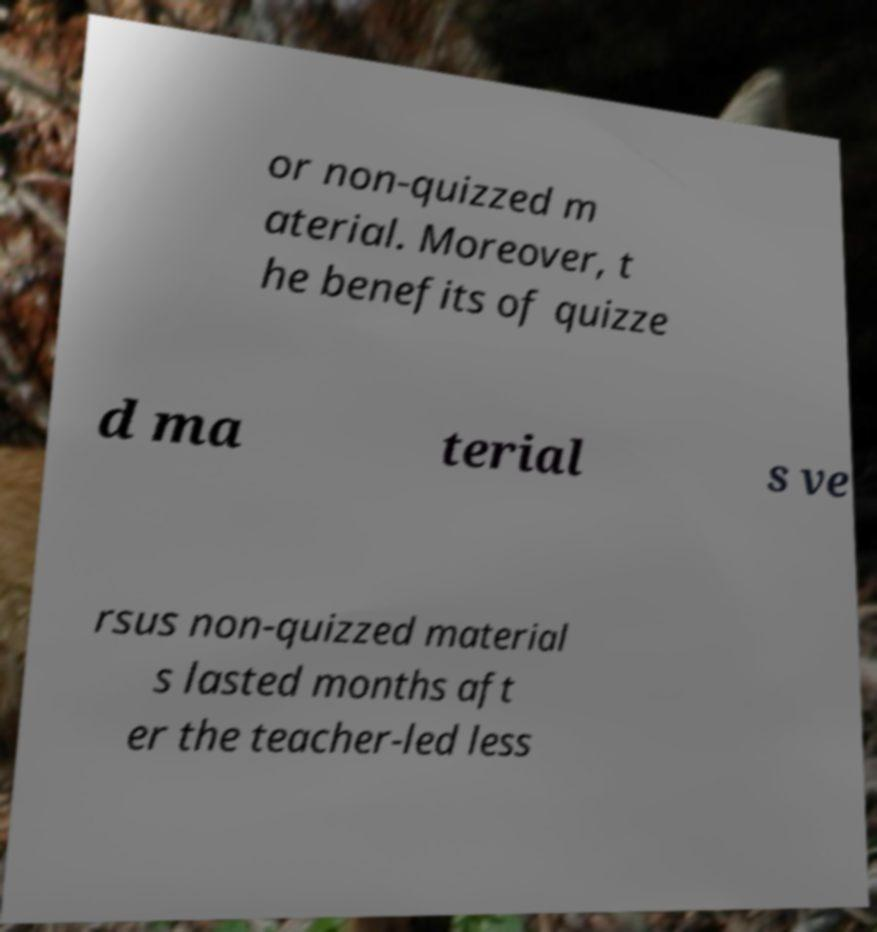There's text embedded in this image that I need extracted. Can you transcribe it verbatim? or non-quizzed m aterial. Moreover, t he benefits of quizze d ma terial s ve rsus non-quizzed material s lasted months aft er the teacher-led less 